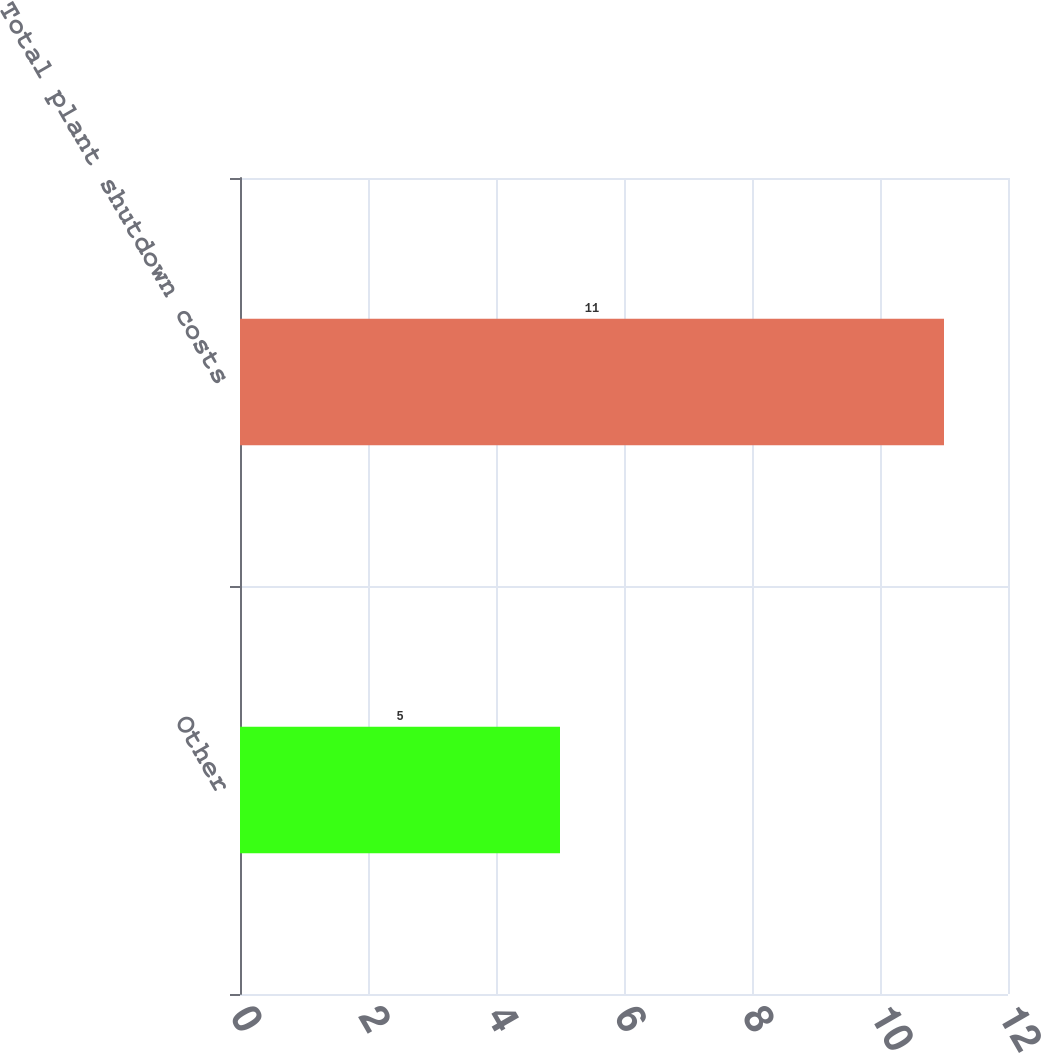Convert chart to OTSL. <chart><loc_0><loc_0><loc_500><loc_500><bar_chart><fcel>Other<fcel>Total plant shutdown costs<nl><fcel>5<fcel>11<nl></chart> 